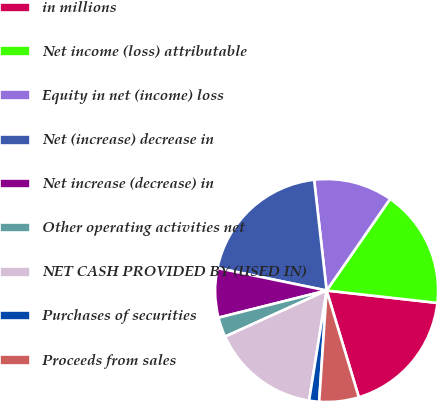Convert chart to OTSL. <chart><loc_0><loc_0><loc_500><loc_500><pie_chart><fcel>in millions<fcel>Net income (loss) attributable<fcel>Equity in net (income) loss<fcel>Net (increase) decrease in<fcel>Net increase (decrease) in<fcel>Other operating activities net<fcel>NET CASH PROVIDED BY (USED IN)<fcel>Purchases of securities<fcel>Proceeds from sales<nl><fcel>18.56%<fcel>17.13%<fcel>11.43%<fcel>19.98%<fcel>7.15%<fcel>2.87%<fcel>15.7%<fcel>1.45%<fcel>5.73%<nl></chart> 